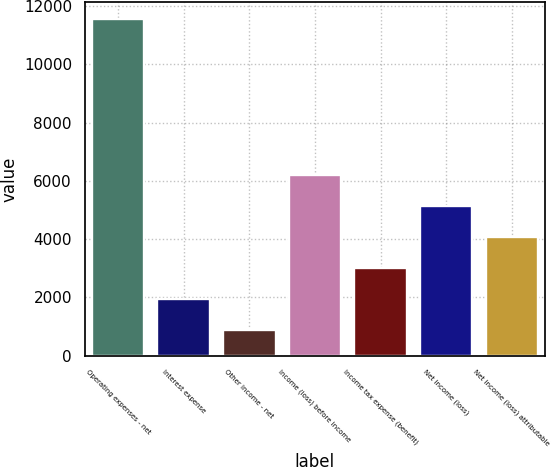<chart> <loc_0><loc_0><loc_500><loc_500><bar_chart><fcel>Operating expenses - net<fcel>Interest expense<fcel>Other income - net<fcel>Income (loss) before income<fcel>Income tax expense (benefit)<fcel>Net income (loss)<fcel>Net income (loss) attributable<nl><fcel>11547<fcel>1940.4<fcel>873<fcel>6210<fcel>3007.8<fcel>5142.6<fcel>4075.2<nl></chart> 